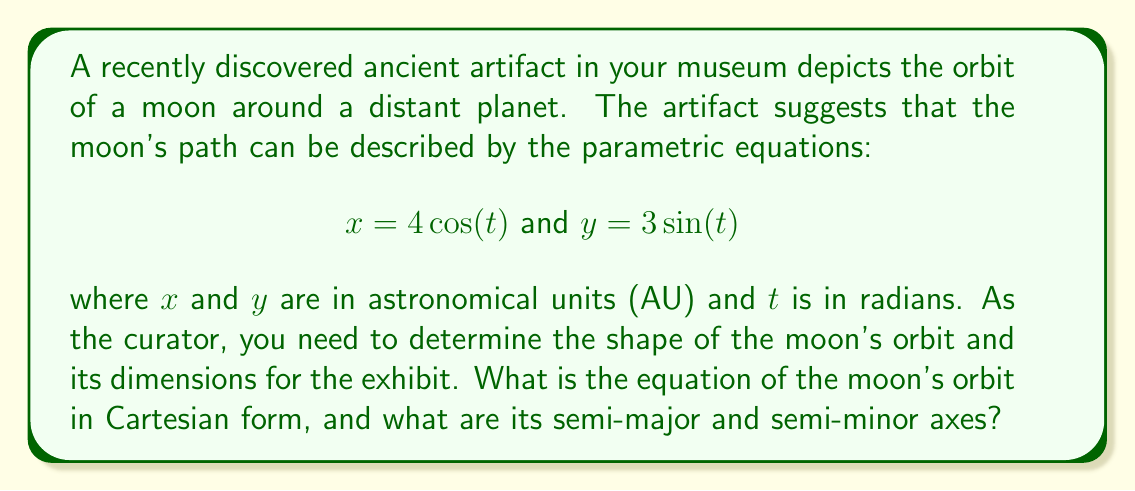Provide a solution to this math problem. To solve this problem, we'll follow these steps:

1) The parametric equations given are:
   $x = 4\cos(t)$
   $y = 3\sin(t)$

2) These equations suggest an elliptical orbit. To confirm this and find the Cartesian equation, we need to eliminate the parameter $t$.

3) First, let's square both equations:
   $x^2 = 16\cos^2(t)$
   $y^2 = 9\sin^2(t)$

4) Now, divide each equation by its right-hand coefficient:
   $\frac{x^2}{16} = \cos^2(t)$
   $\frac{y^2}{9} = \sin^2(t)$

5) Add these equations:
   $\frac{x^2}{16} + \frac{y^2}{9} = \cos^2(t) + \sin^2(t)$

6) Recall the trigonometric identity $\cos^2(t) + \sin^2(t) = 1$. Therefore:
   $\frac{x^2}{16} + \frac{y^2}{9} = 1$

7) This is the standard form of an ellipse centered at the origin.

8) The semi-major and semi-minor axes can be read directly from this equation:
   - The coefficient of $x^2$ is $\frac{1}{16}$, so the semi-major axis is $a = 4$ AU
   - The coefficient of $y^2$ is $\frac{1}{9}$, so the semi-minor axis is $b = 3$ AU

Thus, we have confirmed that the moon's orbit is elliptical, with its semi-major axis along the x-axis and its semi-minor axis along the y-axis.
Answer: The equation of the moon's orbit in Cartesian form is $\frac{x^2}{16} + \frac{y^2}{9} = 1$. The semi-major axis is 4 AU and the semi-minor axis is 3 AU. 